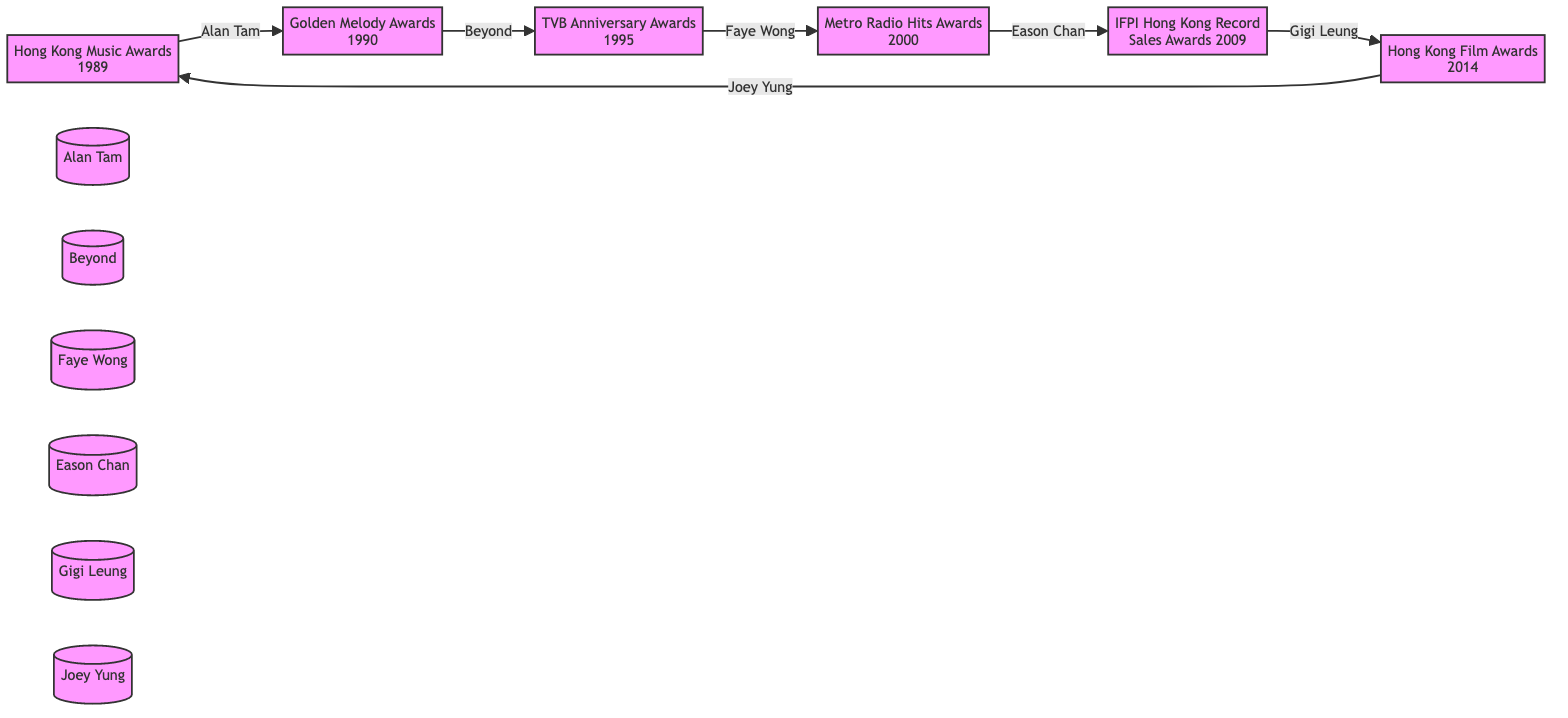What year were the Hong Kong Music Awards held? The diagram indicates that the Hong Kong Music Awards took place in 1989, as it is displayed next to the label.
Answer: 1989 Who won the Golden Melody Awards? The diagram shows that the winner of the Golden Melody Awards is Beyond, which is provided near that label.
Answer: Beyond Which award did Faye Wong win? According to the diagram, Faye Wong won the TVB Anniversary Awards, as indicated by the arrow pointing from her name back to the award.
Answer: TVB Anniversary Awards How many awards are listed in the diagram? By counting the nodes representing the different awards displayed in the diagram, there are a total of 6 distinct awards listed.
Answer: 6 What is the most recent award mentioned in the diagram? The last node in the directed graph indicates the Hong Kong Film Awards, which occurred in 2014, making it the most recent award in the timeline.
Answer: Hong Kong Film Awards Which artist won the award immediately after Eason Chan? The directed graph shows that after Eason Chan's award, Gigi Leung won the IFPI Hong Kong Record Sales Awards, which is the next node in the sequence.
Answer: Gigi Leung What award did Joey Yung win? The square indicating Joey Yung in the diagram specifies that she won the Hong Kong Film Awards, which is stated right next to her name.
Answer: Hong Kong Film Awards Which artist is connected to the Hong Kong Music Awards? The directed graph indicates that Alan Tam is directly connected to the Hong Kong Music Awards, as he is labeled with an arrow pointing towards that award.
Answer: Alan Tam 